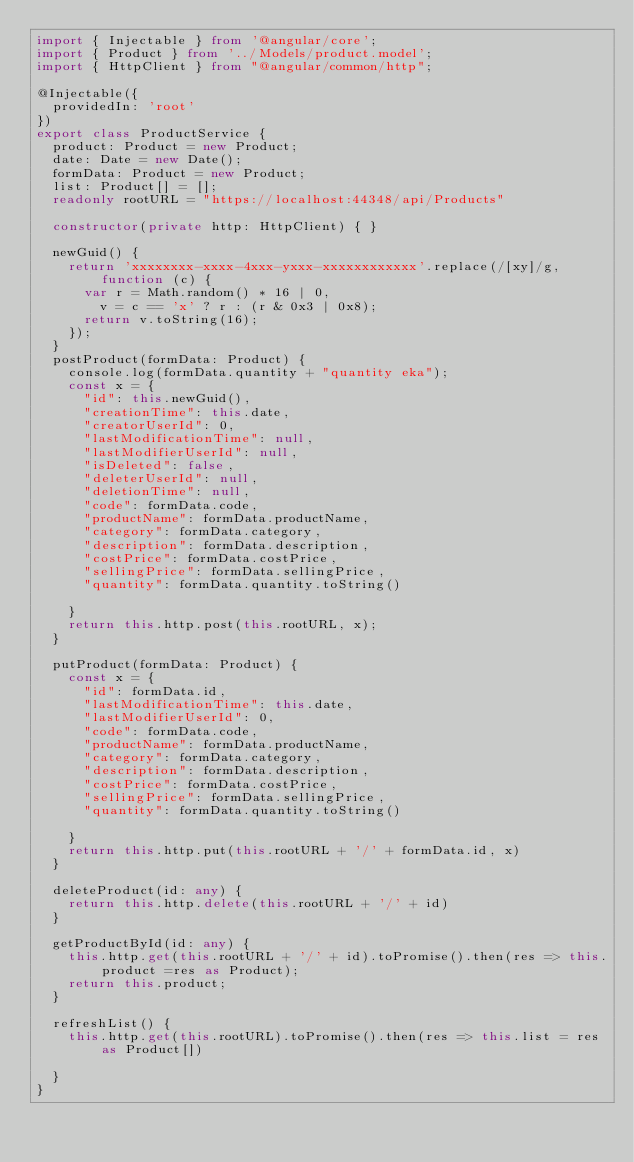Convert code to text. <code><loc_0><loc_0><loc_500><loc_500><_TypeScript_>import { Injectable } from '@angular/core';
import { Product } from '../Models/product.model';
import { HttpClient } from "@angular/common/http";

@Injectable({
  providedIn: 'root'
})
export class ProductService {
  product: Product = new Product;
  date: Date = new Date();
  formData: Product = new Product;
  list: Product[] = [];
  readonly rootURL = "https://localhost:44348/api/Products"

  constructor(private http: HttpClient) { }

  newGuid() {
    return 'xxxxxxxx-xxxx-4xxx-yxxx-xxxxxxxxxxxx'.replace(/[xy]/g, function (c) {
      var r = Math.random() * 16 | 0,
        v = c == 'x' ? r : (r & 0x3 | 0x8);
      return v.toString(16);
    });
  }
  postProduct(formData: Product) {
    console.log(formData.quantity + "quantity eka");
    const x = {
      "id": this.newGuid(),
      "creationTime": this.date,
      "creatorUserId": 0,
      "lastModificationTime": null,
      "lastModifierUserId": null,
      "isDeleted": false,
      "deleterUserId": null,
      "deletionTime": null,
      "code": formData.code,
      "productName": formData.productName,
      "category": formData.category,
      "description": formData.description,
      "costPrice": formData.costPrice,
      "sellingPrice": formData.sellingPrice,
      "quantity": formData.quantity.toString()

    }
    return this.http.post(this.rootURL, x);
  }

  putProduct(formData: Product) {
    const x = {
      "id": formData.id,
      "lastModificationTime": this.date,
      "lastModifierUserId": 0,
      "code": formData.code,
      "productName": formData.productName,
      "category": formData.category,
      "description": formData.description,
      "costPrice": formData.costPrice,
      "sellingPrice": formData.sellingPrice,
      "quantity": formData.quantity.toString()

    }
    return this.http.put(this.rootURL + '/' + formData.id, x)
  }

  deleteProduct(id: any) {
    return this.http.delete(this.rootURL + '/' + id)
  }

  getProductById(id: any) {
    this.http.get(this.rootURL + '/' + id).toPromise().then(res => this.product =res as Product);
    return this.product;
  }

  refreshList() {
    this.http.get(this.rootURL).toPromise().then(res => this.list = res as Product[])

  }
}
</code> 